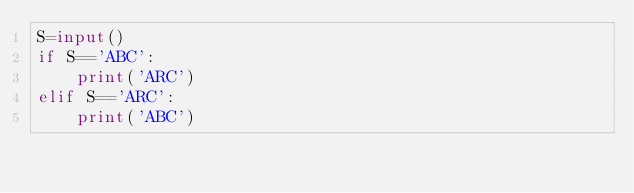Convert code to text. <code><loc_0><loc_0><loc_500><loc_500><_Python_>S=input()
if S=='ABC':
    print('ARC')
elif S=='ARC':
    print('ABC')</code> 